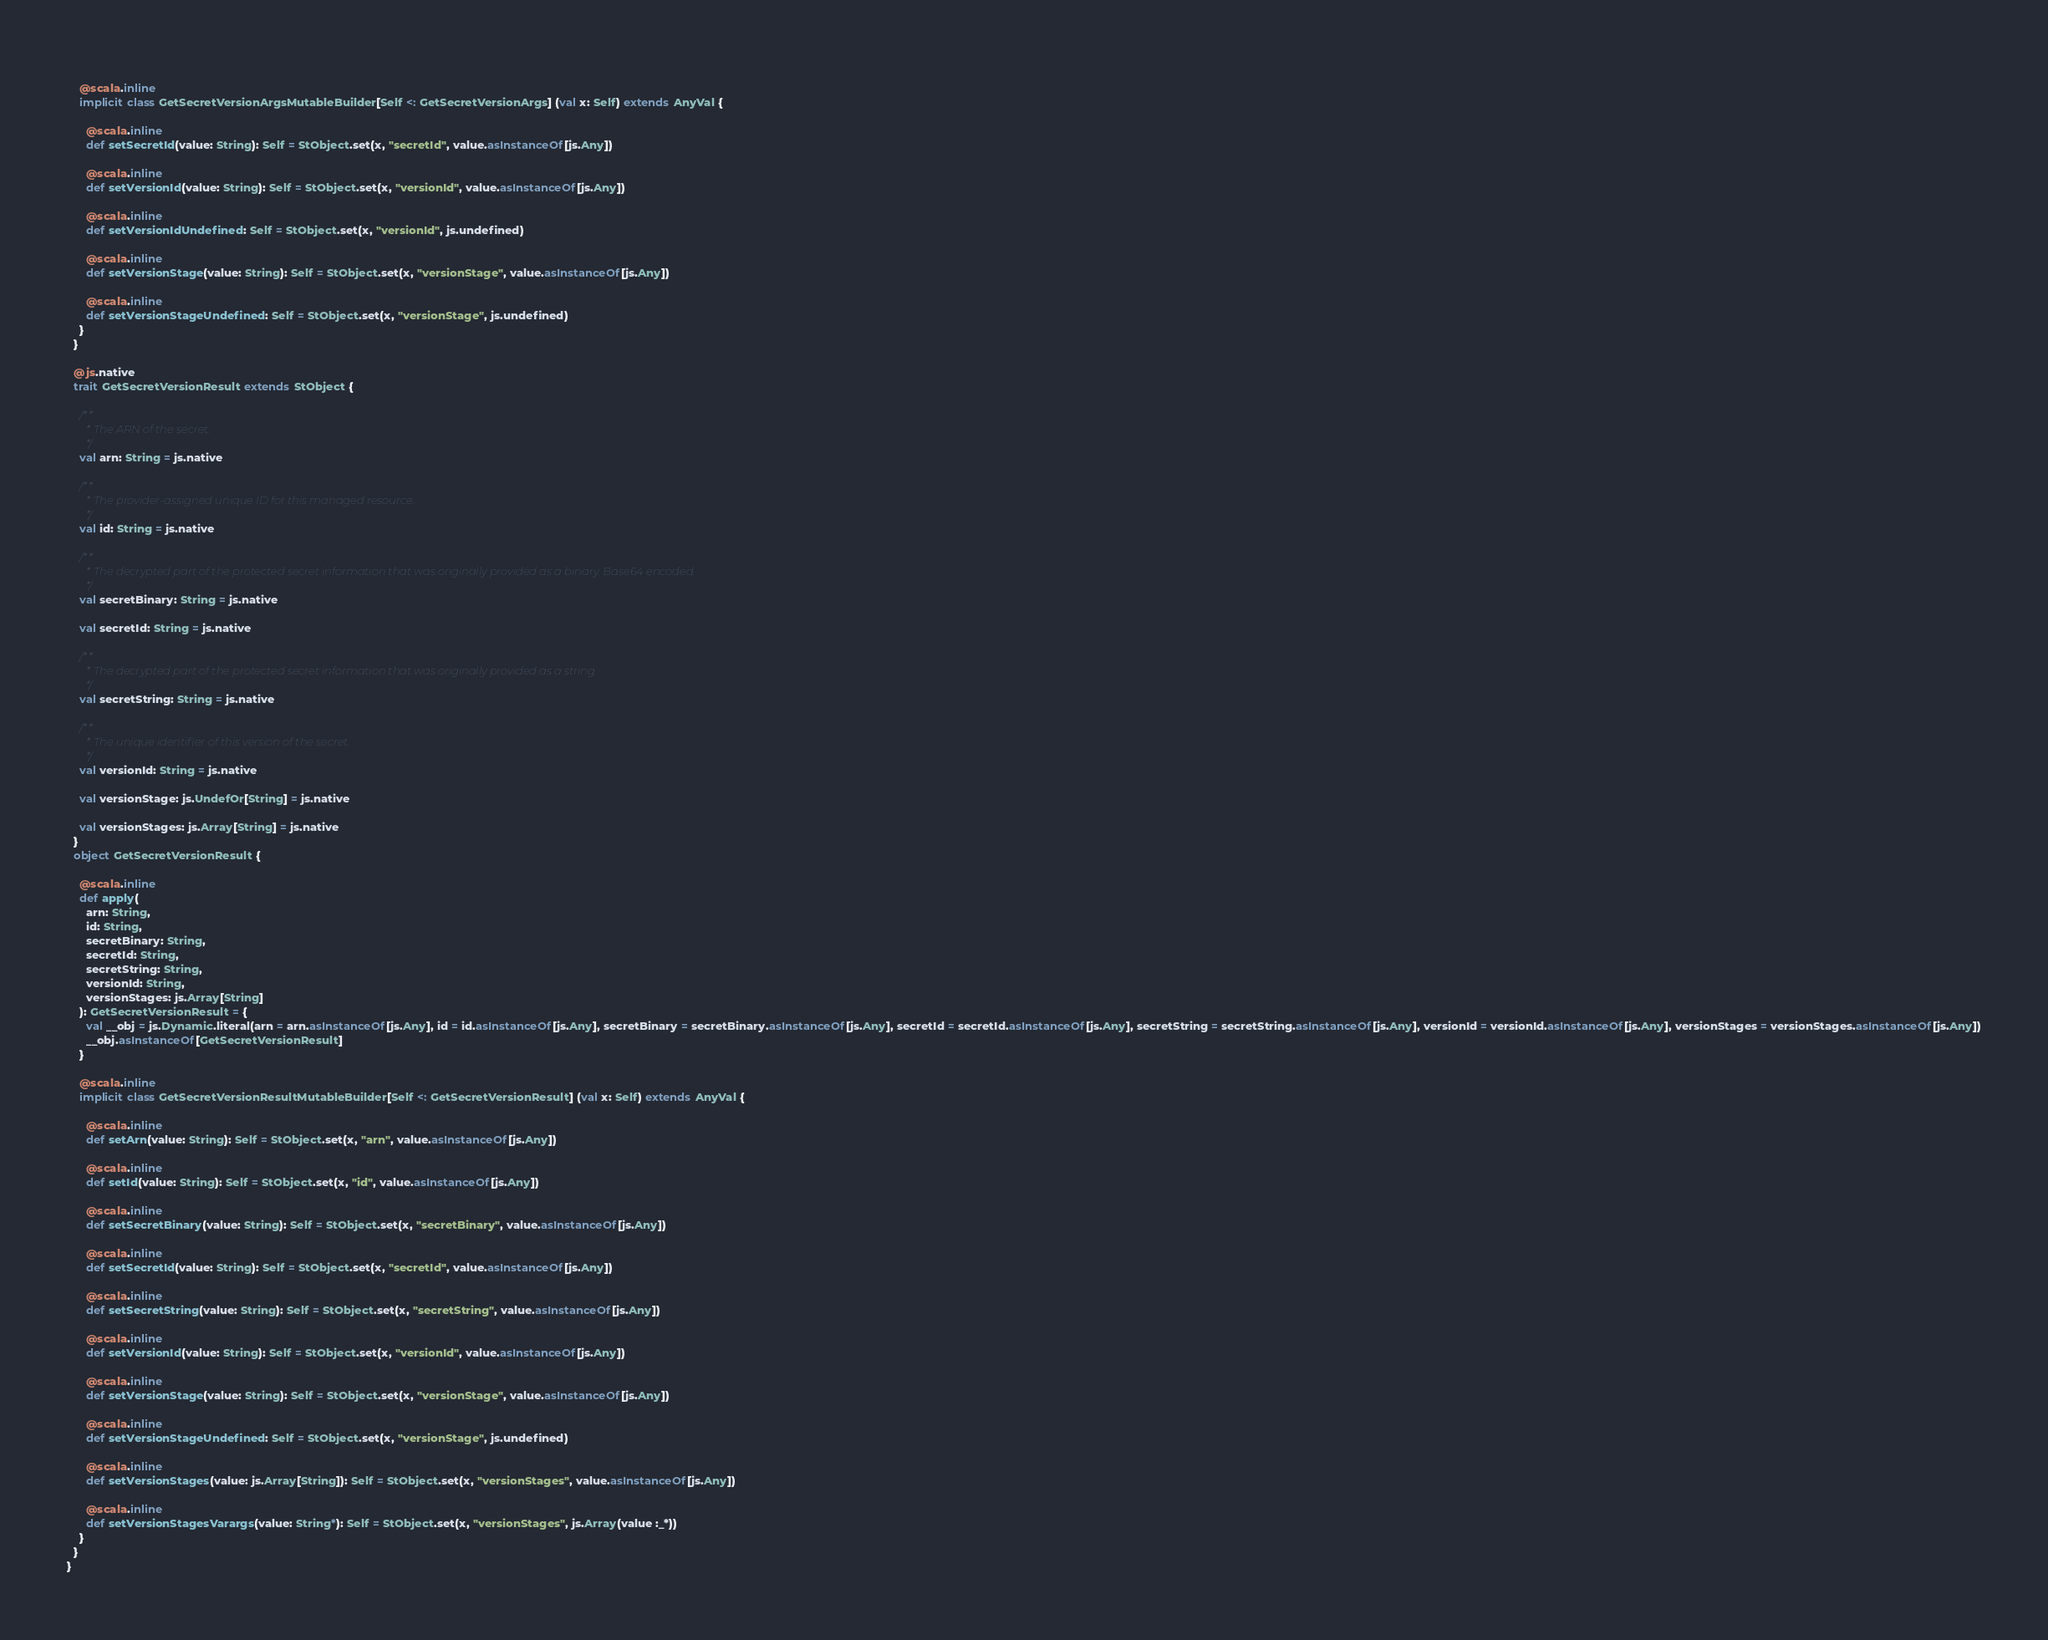Convert code to text. <code><loc_0><loc_0><loc_500><loc_500><_Scala_>    
    @scala.inline
    implicit class GetSecretVersionArgsMutableBuilder[Self <: GetSecretVersionArgs] (val x: Self) extends AnyVal {
      
      @scala.inline
      def setSecretId(value: String): Self = StObject.set(x, "secretId", value.asInstanceOf[js.Any])
      
      @scala.inline
      def setVersionId(value: String): Self = StObject.set(x, "versionId", value.asInstanceOf[js.Any])
      
      @scala.inline
      def setVersionIdUndefined: Self = StObject.set(x, "versionId", js.undefined)
      
      @scala.inline
      def setVersionStage(value: String): Self = StObject.set(x, "versionStage", value.asInstanceOf[js.Any])
      
      @scala.inline
      def setVersionStageUndefined: Self = StObject.set(x, "versionStage", js.undefined)
    }
  }
  
  @js.native
  trait GetSecretVersionResult extends StObject {
    
    /**
      * The ARN of the secret.
      */
    val arn: String = js.native
    
    /**
      * The provider-assigned unique ID for this managed resource.
      */
    val id: String = js.native
    
    /**
      * The decrypted part of the protected secret information that was originally provided as a binary. Base64 encoded.
      */
    val secretBinary: String = js.native
    
    val secretId: String = js.native
    
    /**
      * The decrypted part of the protected secret information that was originally provided as a string.
      */
    val secretString: String = js.native
    
    /**
      * The unique identifier of this version of the secret.
      */
    val versionId: String = js.native
    
    val versionStage: js.UndefOr[String] = js.native
    
    val versionStages: js.Array[String] = js.native
  }
  object GetSecretVersionResult {
    
    @scala.inline
    def apply(
      arn: String,
      id: String,
      secretBinary: String,
      secretId: String,
      secretString: String,
      versionId: String,
      versionStages: js.Array[String]
    ): GetSecretVersionResult = {
      val __obj = js.Dynamic.literal(arn = arn.asInstanceOf[js.Any], id = id.asInstanceOf[js.Any], secretBinary = secretBinary.asInstanceOf[js.Any], secretId = secretId.asInstanceOf[js.Any], secretString = secretString.asInstanceOf[js.Any], versionId = versionId.asInstanceOf[js.Any], versionStages = versionStages.asInstanceOf[js.Any])
      __obj.asInstanceOf[GetSecretVersionResult]
    }
    
    @scala.inline
    implicit class GetSecretVersionResultMutableBuilder[Self <: GetSecretVersionResult] (val x: Self) extends AnyVal {
      
      @scala.inline
      def setArn(value: String): Self = StObject.set(x, "arn", value.asInstanceOf[js.Any])
      
      @scala.inline
      def setId(value: String): Self = StObject.set(x, "id", value.asInstanceOf[js.Any])
      
      @scala.inline
      def setSecretBinary(value: String): Self = StObject.set(x, "secretBinary", value.asInstanceOf[js.Any])
      
      @scala.inline
      def setSecretId(value: String): Self = StObject.set(x, "secretId", value.asInstanceOf[js.Any])
      
      @scala.inline
      def setSecretString(value: String): Self = StObject.set(x, "secretString", value.asInstanceOf[js.Any])
      
      @scala.inline
      def setVersionId(value: String): Self = StObject.set(x, "versionId", value.asInstanceOf[js.Any])
      
      @scala.inline
      def setVersionStage(value: String): Self = StObject.set(x, "versionStage", value.asInstanceOf[js.Any])
      
      @scala.inline
      def setVersionStageUndefined: Self = StObject.set(x, "versionStage", js.undefined)
      
      @scala.inline
      def setVersionStages(value: js.Array[String]): Self = StObject.set(x, "versionStages", value.asInstanceOf[js.Any])
      
      @scala.inline
      def setVersionStagesVarargs(value: String*): Self = StObject.set(x, "versionStages", js.Array(value :_*))
    }
  }
}
</code> 